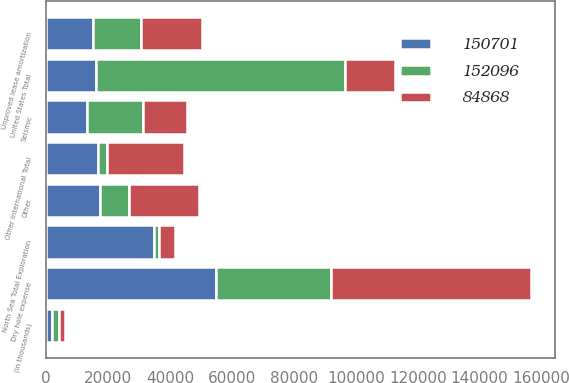<chart> <loc_0><loc_0><loc_500><loc_500><stacked_bar_chart><ecel><fcel>(in thousands)<fcel>Dry hole expense<fcel>Unproved lease amortization<fcel>Seismic<fcel>Other<fcel>United States Total<fcel>North Sea Total Exploration<fcel>Other International Total<nl><fcel>84868<fcel>2002<fcel>64449<fcel>19426<fcel>14282<fcel>22538<fcel>16164.5<fcel>5210<fcel>24796<nl><fcel>150701<fcel>2001<fcel>54810<fcel>15112<fcel>13328<fcel>17242<fcel>16164.5<fcel>34950<fcel>16654<nl><fcel>152096<fcel>2000<fcel>37281<fcel>15675<fcel>17794<fcel>9617<fcel>80367<fcel>1396<fcel>3105<nl></chart> 